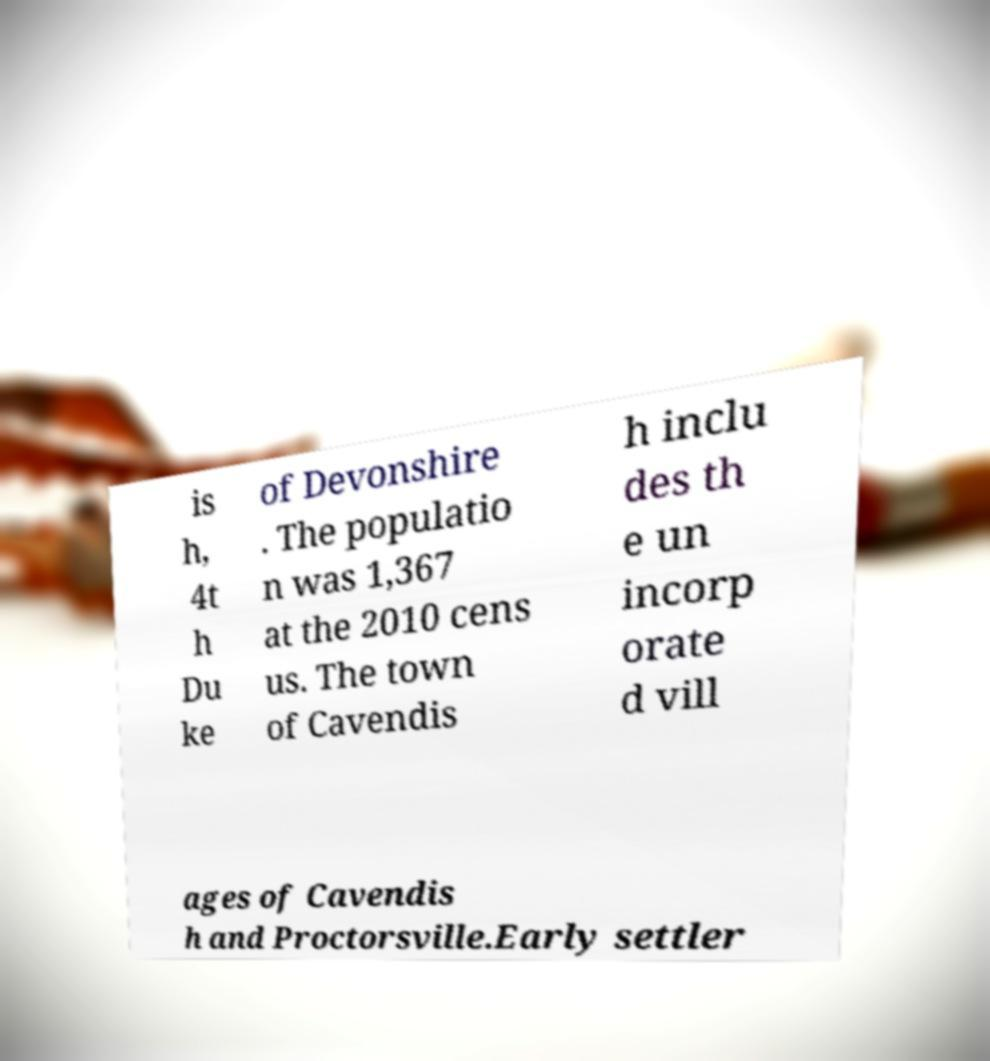What messages or text are displayed in this image? I need them in a readable, typed format. is h, 4t h Du ke of Devonshire . The populatio n was 1,367 at the 2010 cens us. The town of Cavendis h inclu des th e un incorp orate d vill ages of Cavendis h and Proctorsville.Early settler 